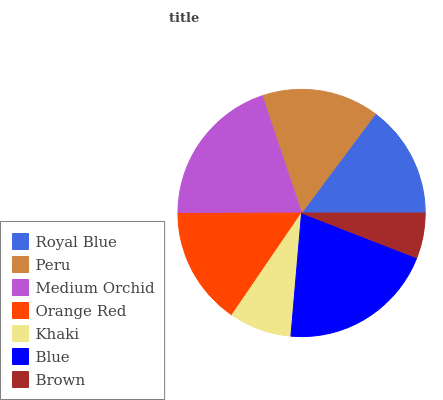Is Brown the minimum?
Answer yes or no. Yes. Is Blue the maximum?
Answer yes or no. Yes. Is Peru the minimum?
Answer yes or no. No. Is Peru the maximum?
Answer yes or no. No. Is Peru greater than Royal Blue?
Answer yes or no. Yes. Is Royal Blue less than Peru?
Answer yes or no. Yes. Is Royal Blue greater than Peru?
Answer yes or no. No. Is Peru less than Royal Blue?
Answer yes or no. No. Is Peru the high median?
Answer yes or no. Yes. Is Peru the low median?
Answer yes or no. Yes. Is Blue the high median?
Answer yes or no. No. Is Khaki the low median?
Answer yes or no. No. 